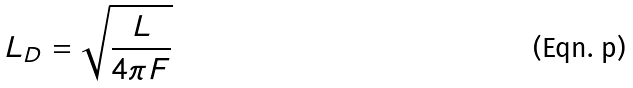Convert formula to latex. <formula><loc_0><loc_0><loc_500><loc_500>L _ { D } = \sqrt { \frac { L } { 4 \pi F } }</formula> 